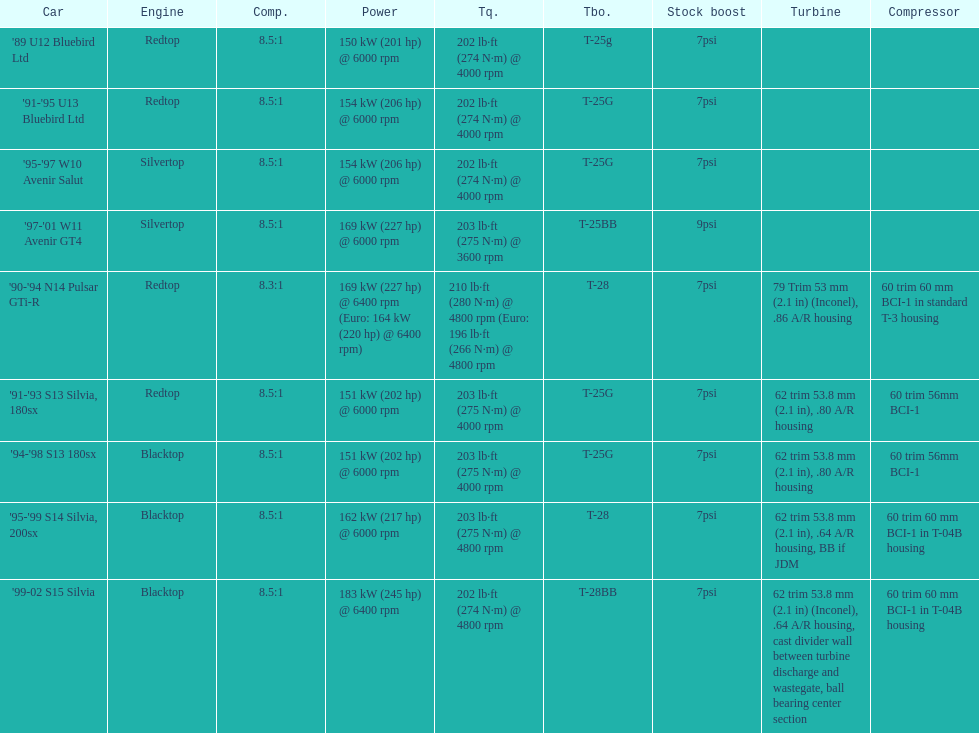Which engine possesses the lowest compression ratio? '90-'94 N14 Pulsar GTi-R. 